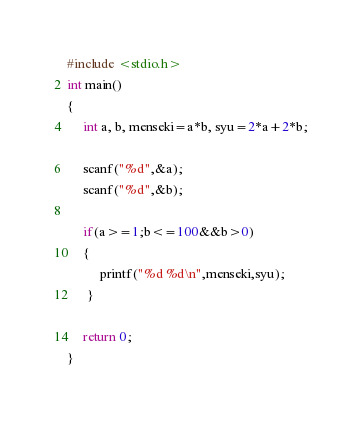Convert code to text. <code><loc_0><loc_0><loc_500><loc_500><_C_>#include <stdio.h>
int main()
{
     int a, b, menseki=a*b, syu=2*a+2*b;

     scanf("%d",&a);
     scanf("%d",&b);

     if(a>=1;b<=100&&b>0)
     {
          printf("%d %d\n",menseki,syu);
      }

     return 0;
}</code> 